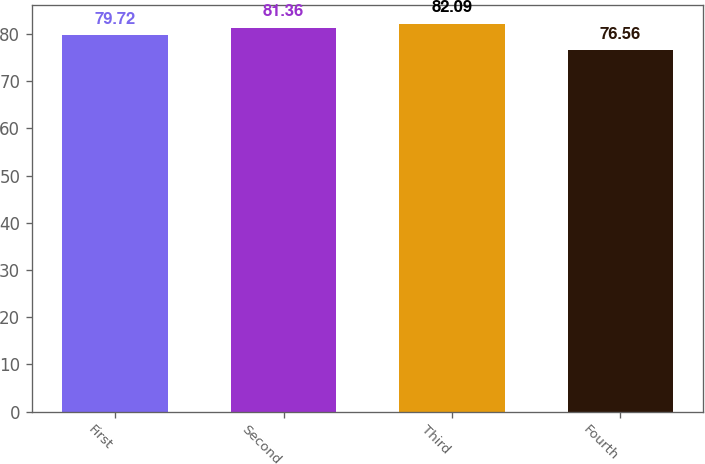<chart> <loc_0><loc_0><loc_500><loc_500><bar_chart><fcel>First<fcel>Second<fcel>Third<fcel>Fourth<nl><fcel>79.72<fcel>81.36<fcel>82.09<fcel>76.56<nl></chart> 